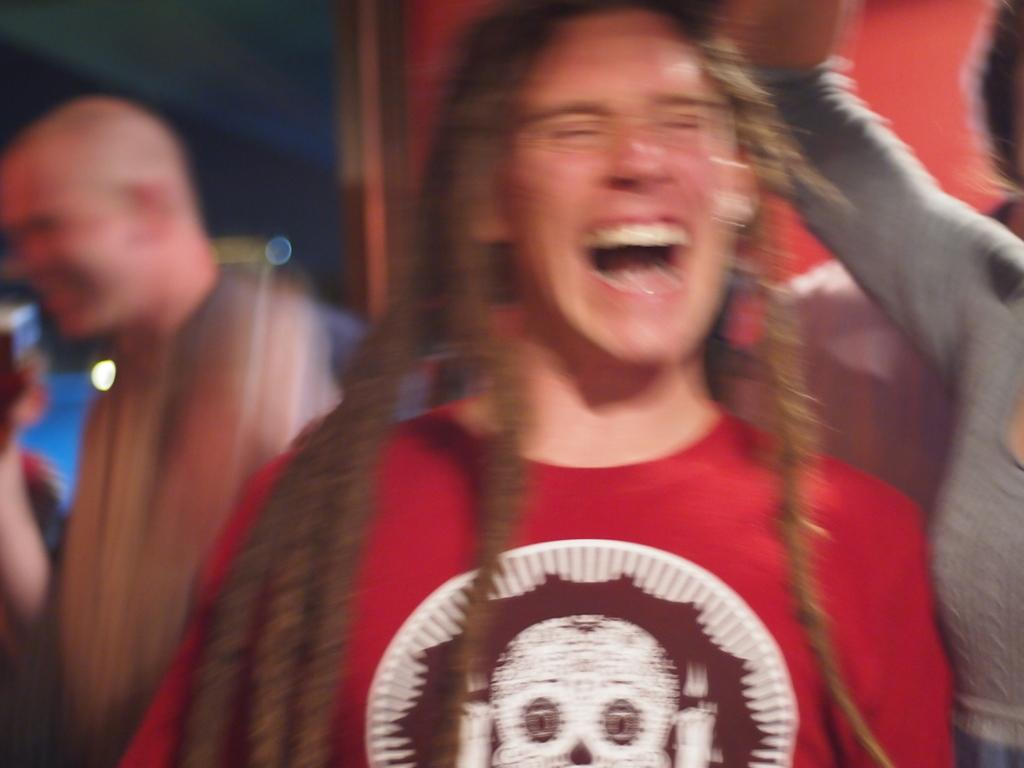What can be observed in the image regarding human presence? There are people standing in the image. Can you describe the background of the image? The background of the image is blurry. What type of tank can be seen in the image? There is no tank present in the image. How many books are visible in the image? There are no books visible in the image. 